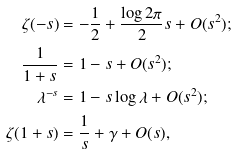Convert formula to latex. <formula><loc_0><loc_0><loc_500><loc_500>\zeta ( - s ) & = - \frac { 1 } { 2 } + \frac { \log 2 \pi } { 2 } s + O ( s ^ { 2 } ) ; \\ \frac { 1 } { 1 + s } & = 1 - s + O ( s ^ { 2 } ) ; \\ \lambda ^ { - s } & = 1 - s \log \lambda + O ( s ^ { 2 } ) ; \\ \zeta ( 1 + s ) & = \frac { 1 } { s } + \gamma + O ( s ) ,</formula> 